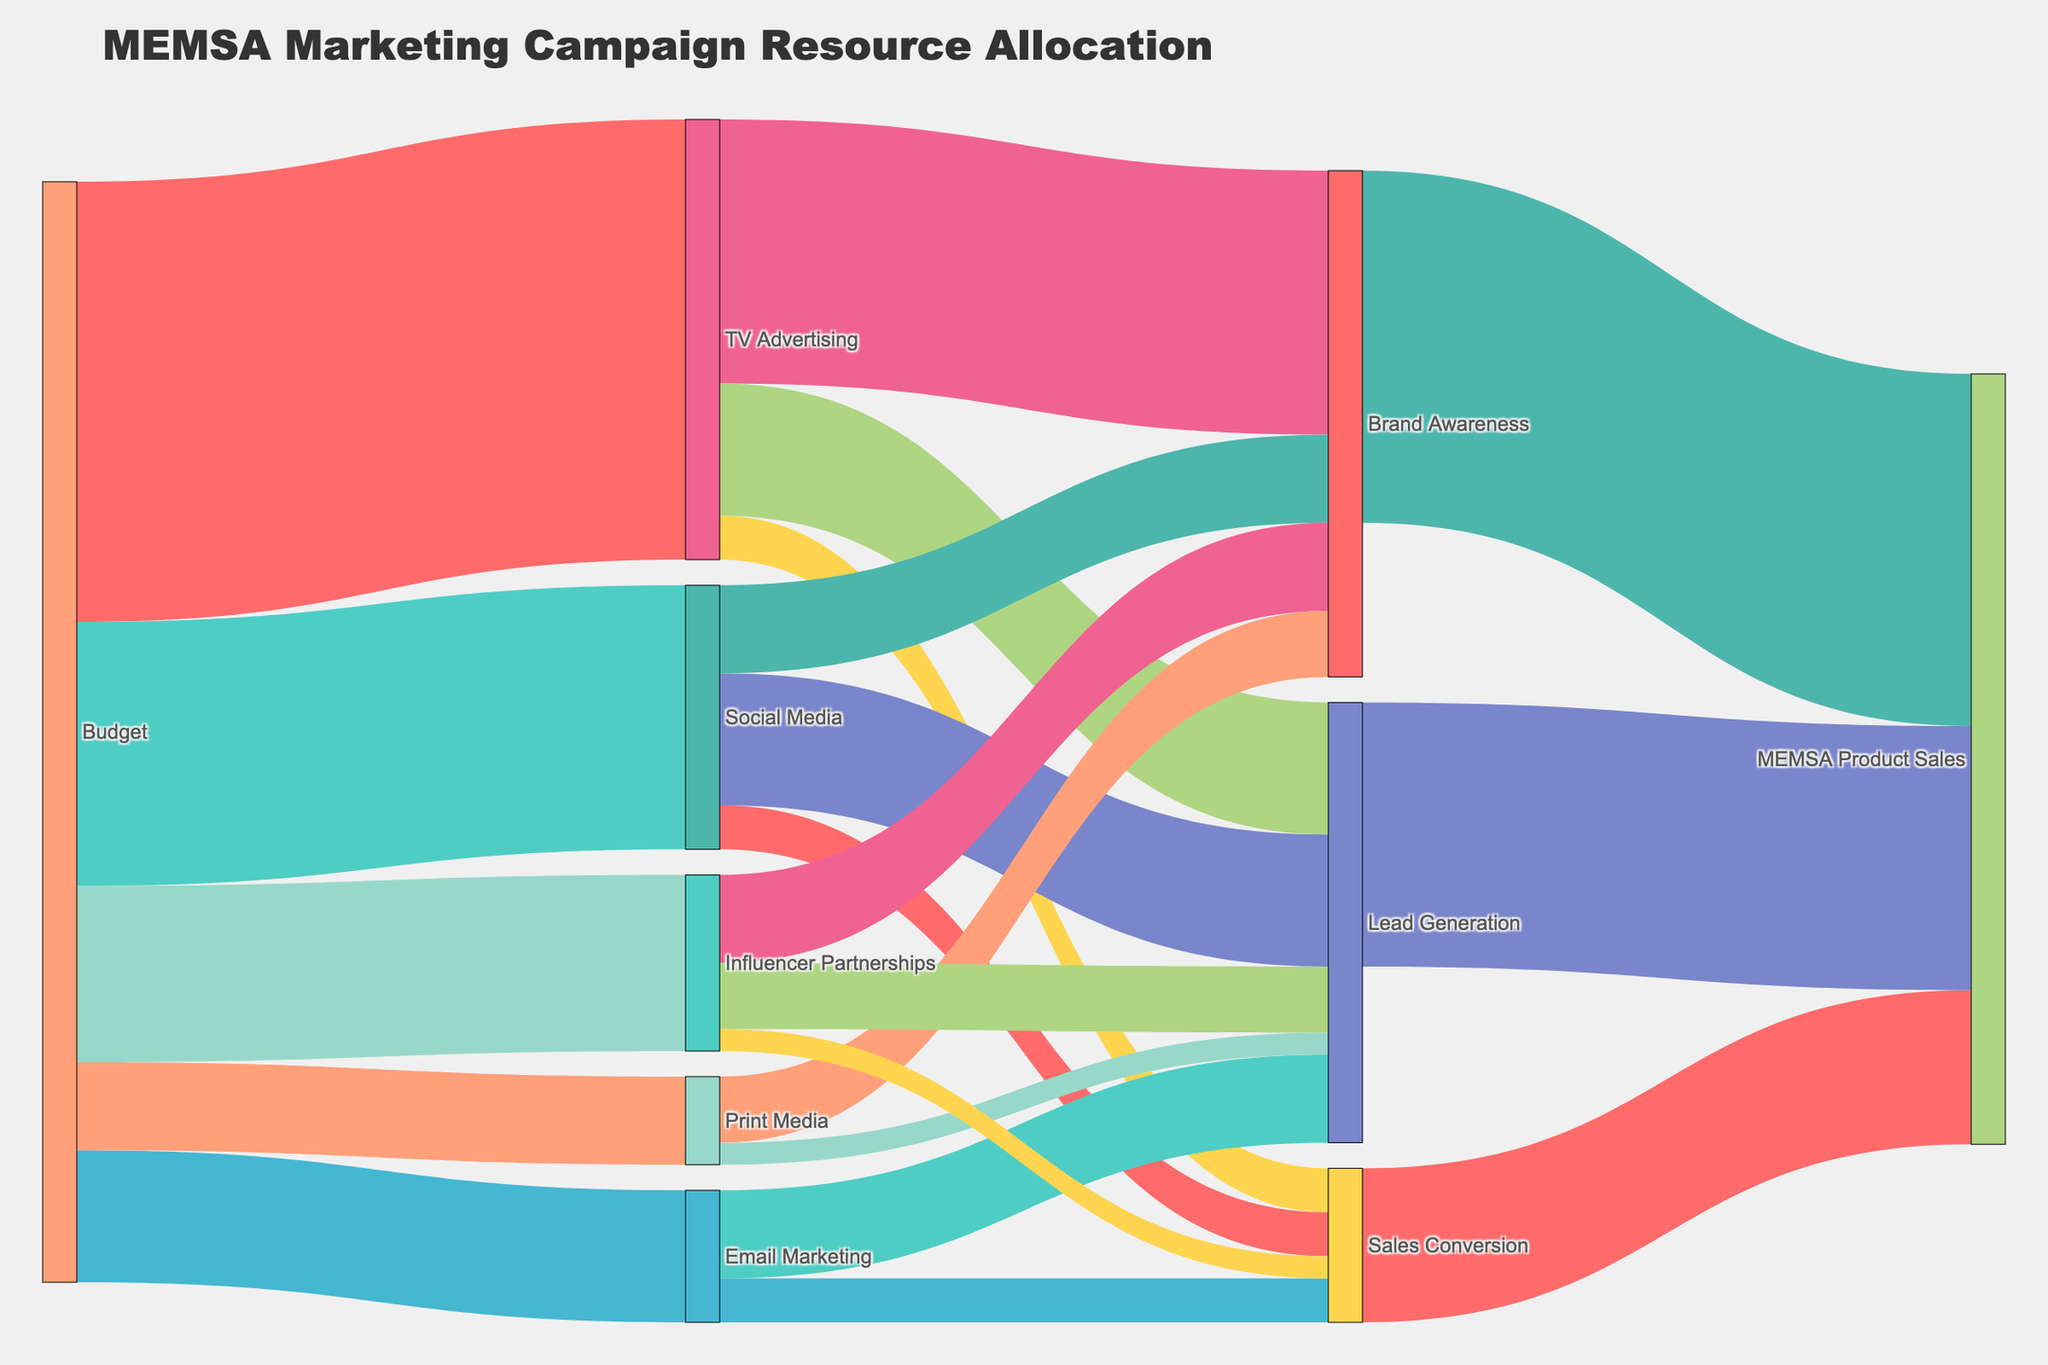How much budget was allocated to Social Media? Locate the "Budget" node and follow the links to "Social Media". The width of the link and the attached value show the budget allocated to Social Media.
Answer: $300,000 Which channel received the highest allocation from the budget? Compare the width of the links originating from the "Budget" node to determine the highest allocation. The "TV Advertising" link is the widest and has the highest value.
Answer: TV Advertising What is the total budget allocated to Email Marketing and Print Media combined? Find the values allocated to "Email Marketing" ($150,000) and "Print Media" ($100,000) and add them together.
Answer: $250,000 What outcome received the most resources from TV Advertising? Check the destinations of the links from "TV Advertising". The link to "Brand Awareness" is the widest and has the highest value.
Answer: Brand Awareness How much total budget went into Sales Conversion through Email Marketing and Social Media? Sum the values flowing into "Sales Conversion" from "Email Marketing" ($50,000) and "Social Media" ($50,000).
Answer: $100,000 What is the total contribution of Brand Awareness to MEMSA Product Sales? Sum the values from "Brand Awareness" to "MEMSA Product Sales", which is directly given as $400,000.
Answer: $400,000 How do the resources allocated to Influencer Partnerships compare to those allocated to Print Media? Compare the widths and values of links originating from "Budget" to "Influencer Partnerships" ($200,000) and "Print Media" ($100,000). Influencer Partnerships received twice as much.
Answer: Influencer Partnerships are higher What is the ratio of the funds allocated to TV Advertising to the total budget? Divide the value allocated to "TV Advertising" ($500,000) by the total budget (sum of all allocated values from the “Budget” node: $1,250,000).
Answer: 0.4 (or 40%) How much revenue was generated from Lead Generation? Find the link from "Lead Generation" to "MEMSA Product Sales" which shows the value as $300,000.
Answer: $300,000 What percentage of the budget for Social Media led to Lead Generation? Find the values: Social Media budget ($300,000), allocation to Lead Generation ($150,000), then calculate (150,000 / 300,000) * 100.
Answer: 50% 